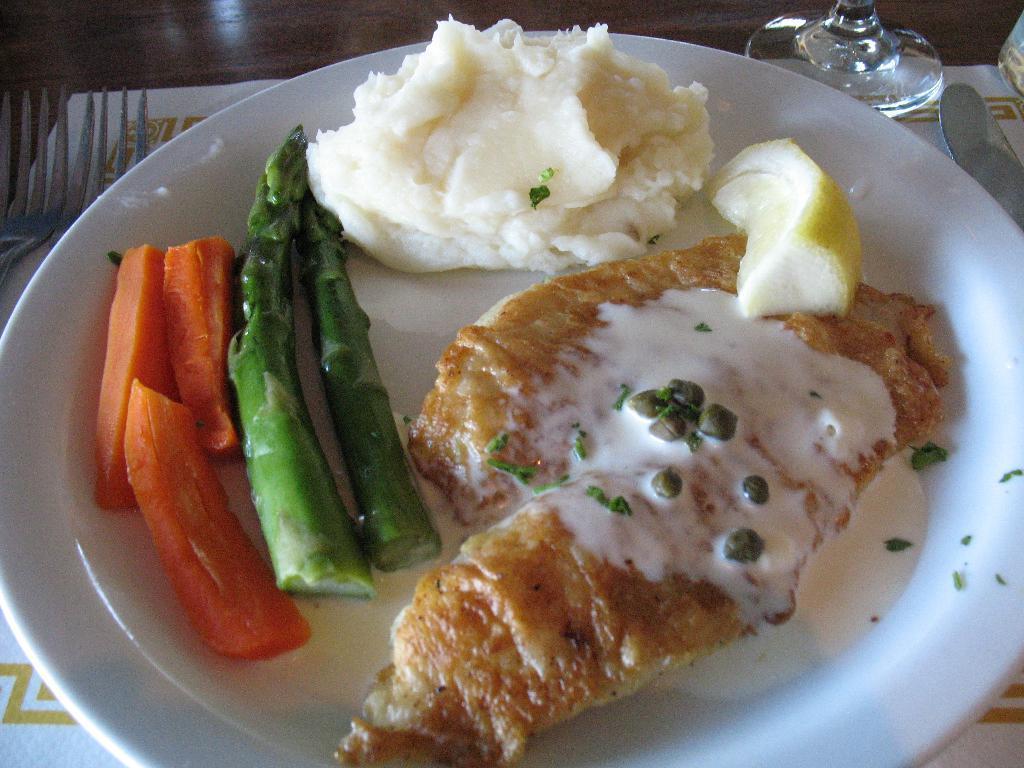What is on the plate in the image? There is food on a plate in the image. Where is the plate located? The plate is on a table in the image. What utensil is to the left of the plate? There is a fork to the left of the plate in the image. What is to the right side of the plate? There is a glass to the right side of the plate in the image. What is under the plate? There is a paper under the plate in the image. What type of zinc is present in the image? There is no zinc present in the image. Can you describe the swing in the image? There is no swing present in the image. 